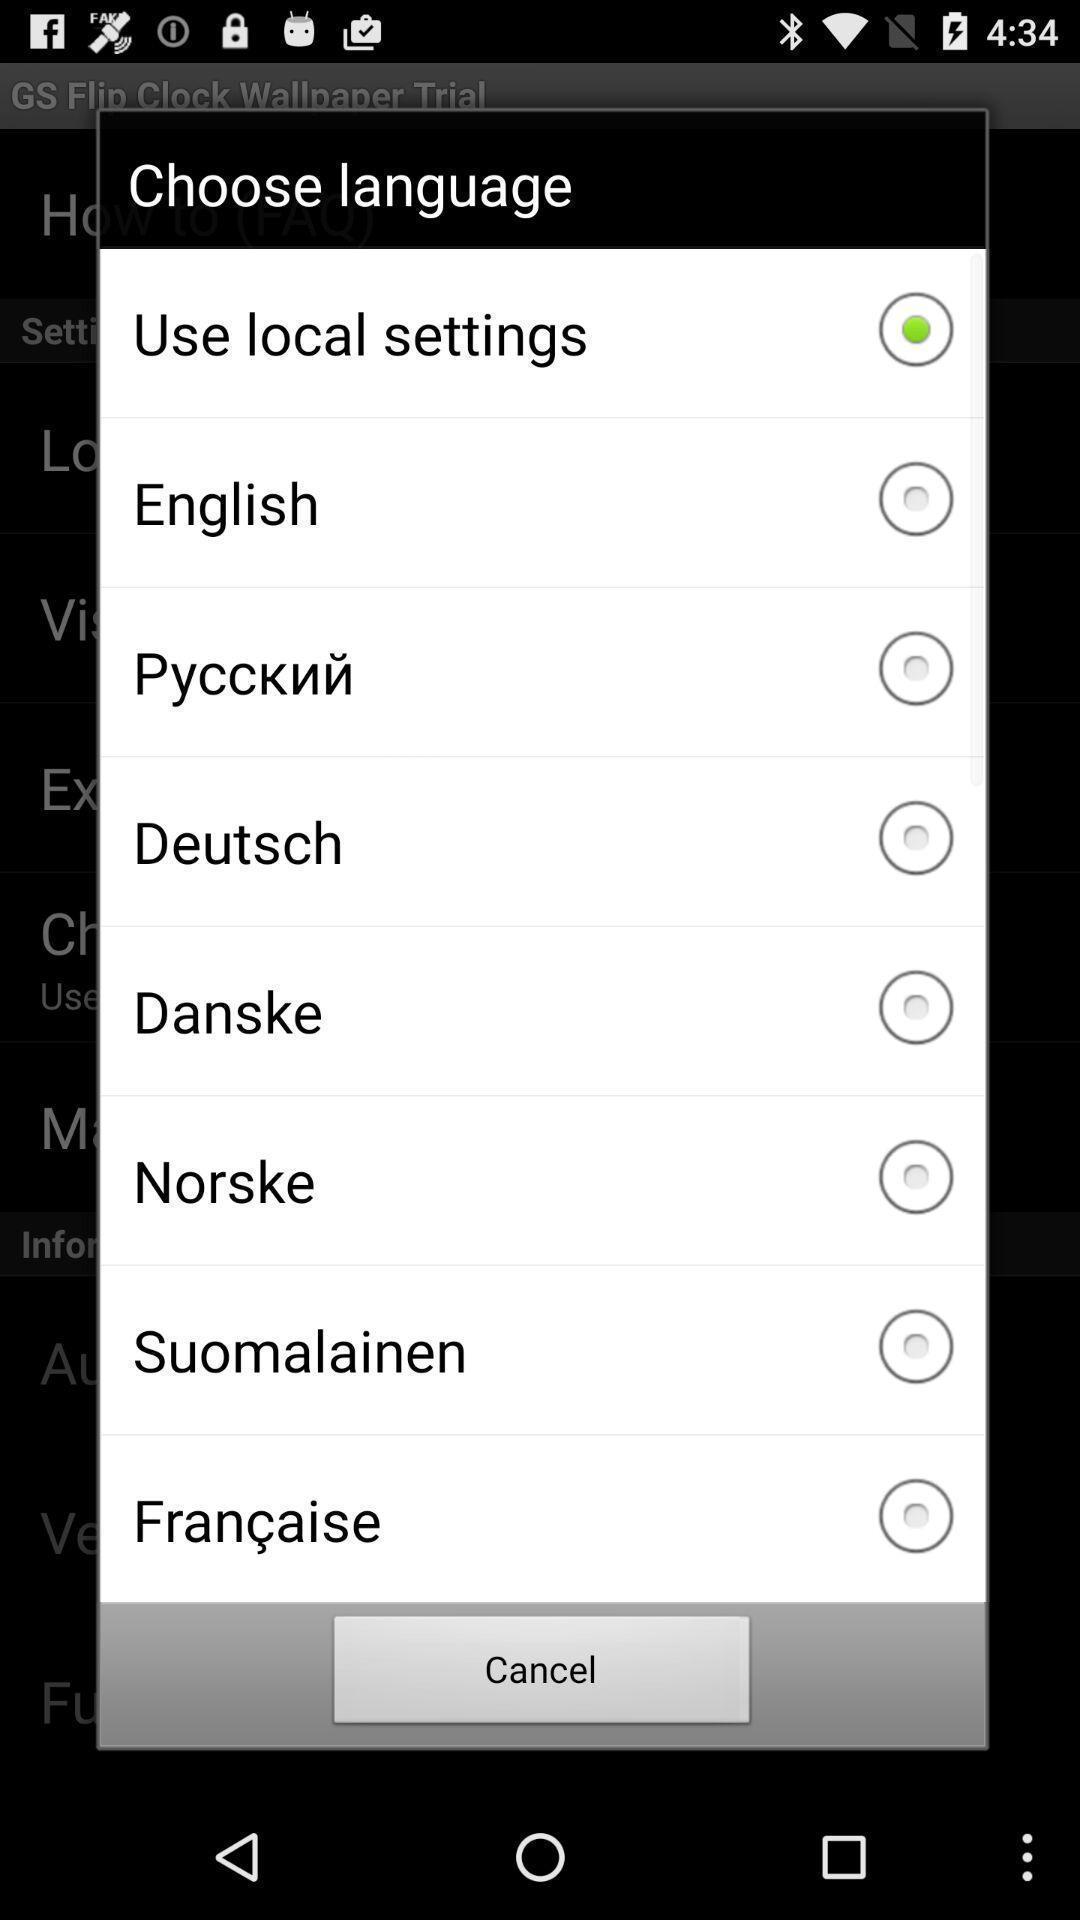Please provide a description for this image. Pop-up to choose a language. 